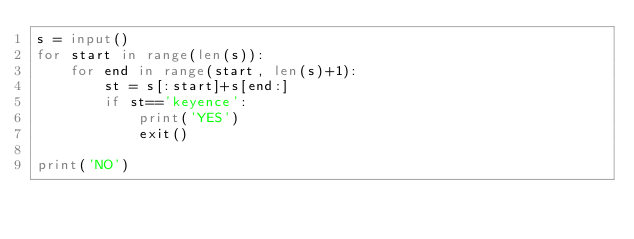Convert code to text. <code><loc_0><loc_0><loc_500><loc_500><_Python_>s = input()
for start in range(len(s)):
    for end in range(start, len(s)+1):
        st = s[:start]+s[end:]
        if st=='keyence':
            print('YES')
            exit()

print('NO')</code> 